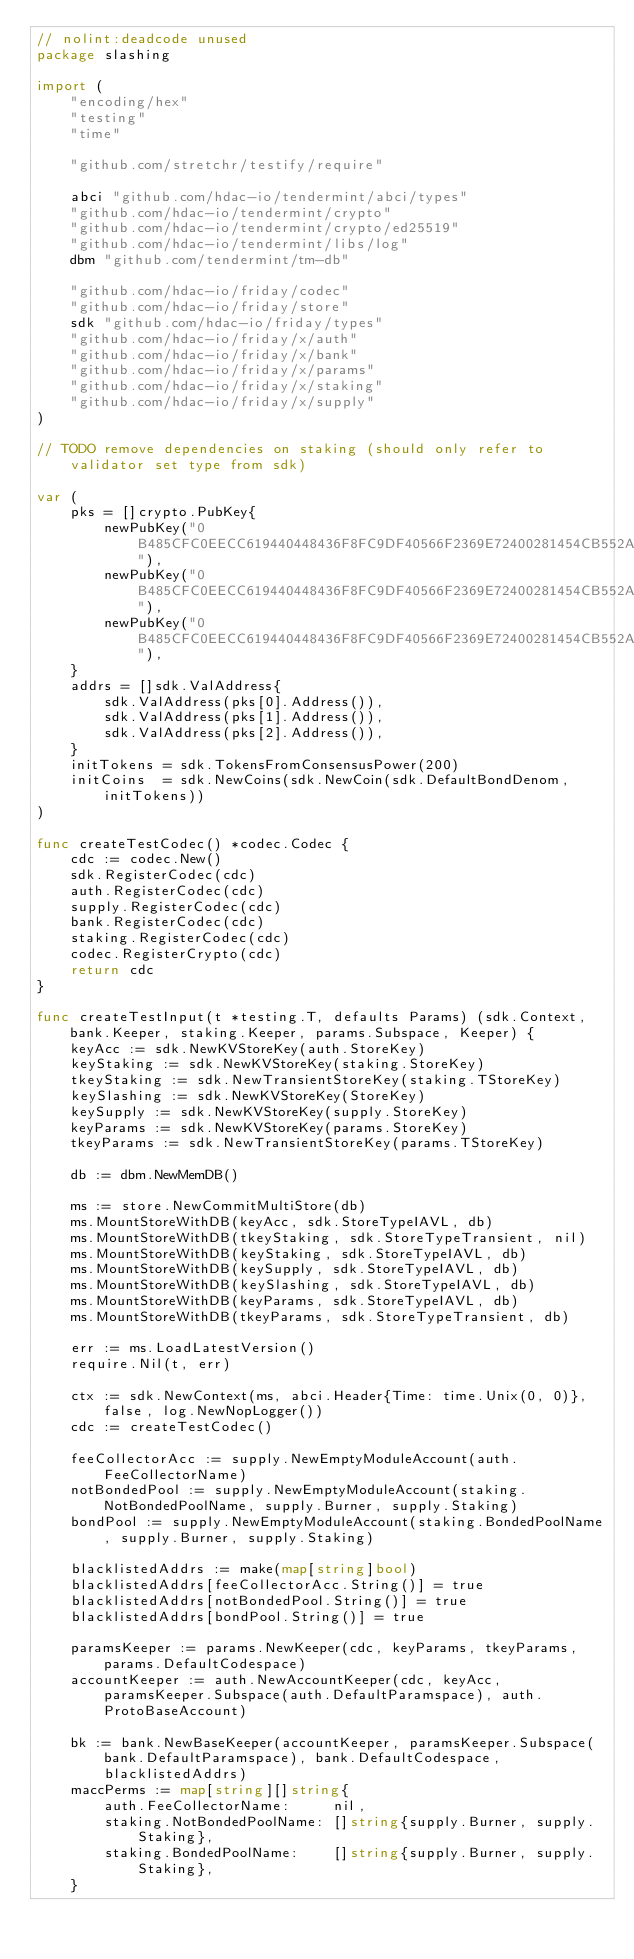Convert code to text. <code><loc_0><loc_0><loc_500><loc_500><_Go_>// nolint:deadcode unused
package slashing

import (
	"encoding/hex"
	"testing"
	"time"

	"github.com/stretchr/testify/require"

	abci "github.com/hdac-io/tendermint/abci/types"
	"github.com/hdac-io/tendermint/crypto"
	"github.com/hdac-io/tendermint/crypto/ed25519"
	"github.com/hdac-io/tendermint/libs/log"
	dbm "github.com/tendermint/tm-db"

	"github.com/hdac-io/friday/codec"
	"github.com/hdac-io/friday/store"
	sdk "github.com/hdac-io/friday/types"
	"github.com/hdac-io/friday/x/auth"
	"github.com/hdac-io/friday/x/bank"
	"github.com/hdac-io/friday/x/params"
	"github.com/hdac-io/friday/x/staking"
	"github.com/hdac-io/friday/x/supply"
)

// TODO remove dependencies on staking (should only refer to validator set type from sdk)

var (
	pks = []crypto.PubKey{
		newPubKey("0B485CFC0EECC619440448436F8FC9DF40566F2369E72400281454CB552AFB50"),
		newPubKey("0B485CFC0EECC619440448436F8FC9DF40566F2369E72400281454CB552AFB51"),
		newPubKey("0B485CFC0EECC619440448436F8FC9DF40566F2369E72400281454CB552AFB52"),
	}
	addrs = []sdk.ValAddress{
		sdk.ValAddress(pks[0].Address()),
		sdk.ValAddress(pks[1].Address()),
		sdk.ValAddress(pks[2].Address()),
	}
	initTokens = sdk.TokensFromConsensusPower(200)
	initCoins  = sdk.NewCoins(sdk.NewCoin(sdk.DefaultBondDenom, initTokens))
)

func createTestCodec() *codec.Codec {
	cdc := codec.New()
	sdk.RegisterCodec(cdc)
	auth.RegisterCodec(cdc)
	supply.RegisterCodec(cdc)
	bank.RegisterCodec(cdc)
	staking.RegisterCodec(cdc)
	codec.RegisterCrypto(cdc)
	return cdc
}

func createTestInput(t *testing.T, defaults Params) (sdk.Context, bank.Keeper, staking.Keeper, params.Subspace, Keeper) {
	keyAcc := sdk.NewKVStoreKey(auth.StoreKey)
	keyStaking := sdk.NewKVStoreKey(staking.StoreKey)
	tkeyStaking := sdk.NewTransientStoreKey(staking.TStoreKey)
	keySlashing := sdk.NewKVStoreKey(StoreKey)
	keySupply := sdk.NewKVStoreKey(supply.StoreKey)
	keyParams := sdk.NewKVStoreKey(params.StoreKey)
	tkeyParams := sdk.NewTransientStoreKey(params.TStoreKey)

	db := dbm.NewMemDB()

	ms := store.NewCommitMultiStore(db)
	ms.MountStoreWithDB(keyAcc, sdk.StoreTypeIAVL, db)
	ms.MountStoreWithDB(tkeyStaking, sdk.StoreTypeTransient, nil)
	ms.MountStoreWithDB(keyStaking, sdk.StoreTypeIAVL, db)
	ms.MountStoreWithDB(keySupply, sdk.StoreTypeIAVL, db)
	ms.MountStoreWithDB(keySlashing, sdk.StoreTypeIAVL, db)
	ms.MountStoreWithDB(keyParams, sdk.StoreTypeIAVL, db)
	ms.MountStoreWithDB(tkeyParams, sdk.StoreTypeTransient, db)

	err := ms.LoadLatestVersion()
	require.Nil(t, err)

	ctx := sdk.NewContext(ms, abci.Header{Time: time.Unix(0, 0)}, false, log.NewNopLogger())
	cdc := createTestCodec()

	feeCollectorAcc := supply.NewEmptyModuleAccount(auth.FeeCollectorName)
	notBondedPool := supply.NewEmptyModuleAccount(staking.NotBondedPoolName, supply.Burner, supply.Staking)
	bondPool := supply.NewEmptyModuleAccount(staking.BondedPoolName, supply.Burner, supply.Staking)

	blacklistedAddrs := make(map[string]bool)
	blacklistedAddrs[feeCollectorAcc.String()] = true
	blacklistedAddrs[notBondedPool.String()] = true
	blacklistedAddrs[bondPool.String()] = true

	paramsKeeper := params.NewKeeper(cdc, keyParams, tkeyParams, params.DefaultCodespace)
	accountKeeper := auth.NewAccountKeeper(cdc, keyAcc, paramsKeeper.Subspace(auth.DefaultParamspace), auth.ProtoBaseAccount)

	bk := bank.NewBaseKeeper(accountKeeper, paramsKeeper.Subspace(bank.DefaultParamspace), bank.DefaultCodespace, blacklistedAddrs)
	maccPerms := map[string][]string{
		auth.FeeCollectorName:     nil,
		staking.NotBondedPoolName: []string{supply.Burner, supply.Staking},
		staking.BondedPoolName:    []string{supply.Burner, supply.Staking},
	}</code> 